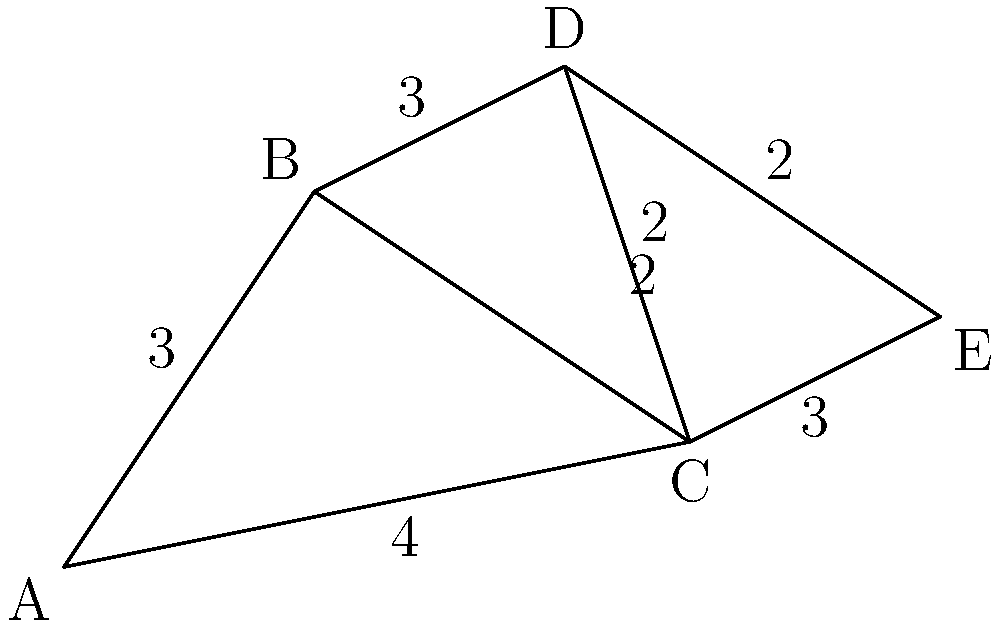As a travel blogger exploring fusion restaurants in a new city, you've identified five popular establishments (A, B, C, D, and E) on a street map. The distances between connected restaurants are shown in kilometers. What is the shortest route that allows you to visit all five restaurants, starting and ending at restaurant A? To find the shortest route visiting all restaurants and returning to A, we need to solve the Traveling Salesman Problem. For a small graph like this, we can use a systematic approach:

1. List all possible routes starting and ending at A:
   A-B-C-D-E-A, A-B-C-E-D-A, A-B-D-C-E-A, A-B-D-E-C-A, A-C-B-D-E-A, A-C-D-B-E-A, A-C-E-D-B-A

2. Calculate the total distance for each route:
   A-B-C-D-E-A: 3 + 2 + 2 + 2 + 7 = 16 km
   A-B-C-E-D-A: 3 + 2 + 3 + 2 + 3 = 13 km
   A-B-D-C-E-A: 3 + 3 + 2 + 3 + 4 = 15 km
   A-B-D-E-C-A: 3 + 3 + 2 + 3 + 4 = 15 km
   A-C-B-D-E-A: 4 + 2 + 3 + 2 + 7 = 18 km
   A-C-D-B-E-A: 4 + 2 + 3 + 3 + 7 = 19 km
   A-C-E-D-B-A: 4 + 3 + 2 + 3 + 3 = 15 km

3. Identify the shortest route:
   A-B-C-E-D-A with a total distance of 13 km.

Therefore, the optimal route for visiting all fusion restaurants is A → B → C → E → D → A, covering a total distance of 13 km.
Answer: A-B-C-E-D-A (13 km) 